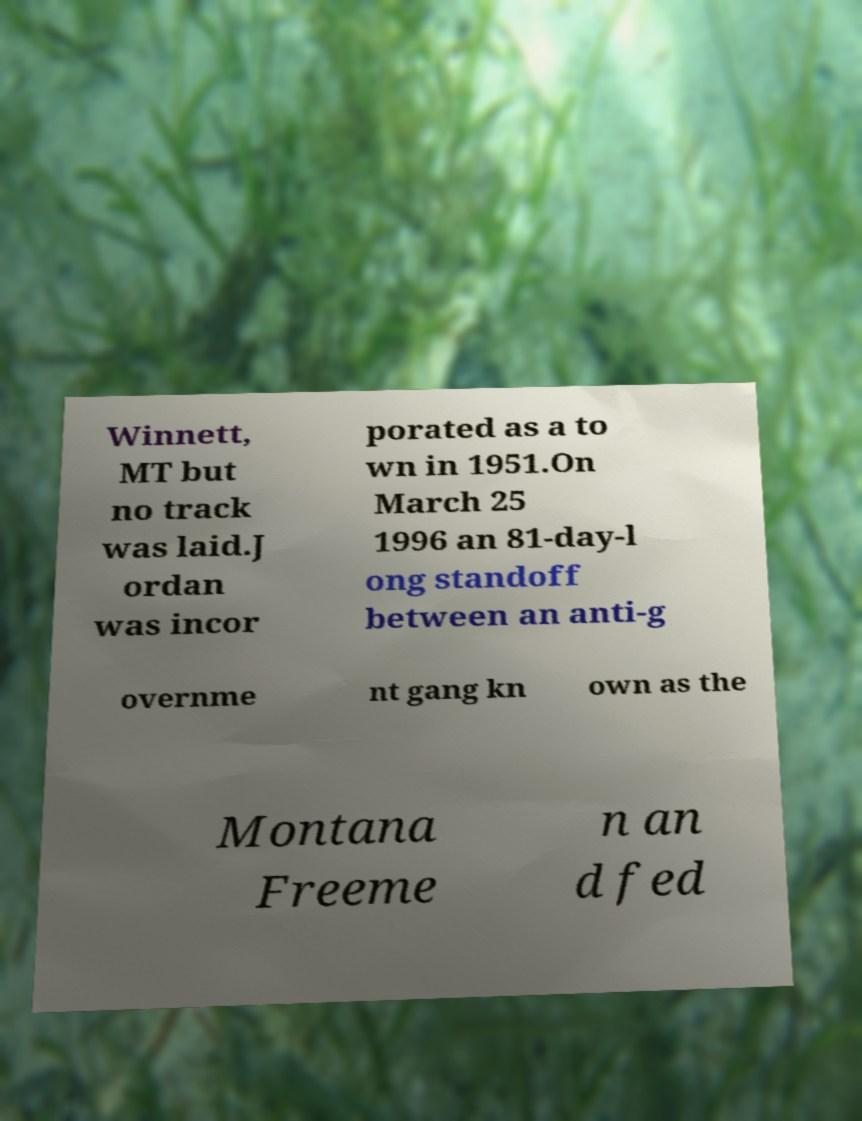Can you read and provide the text displayed in the image?This photo seems to have some interesting text. Can you extract and type it out for me? Winnett, MT but no track was laid.J ordan was incor porated as a to wn in 1951.On March 25 1996 an 81-day-l ong standoff between an anti-g overnme nt gang kn own as the Montana Freeme n an d fed 